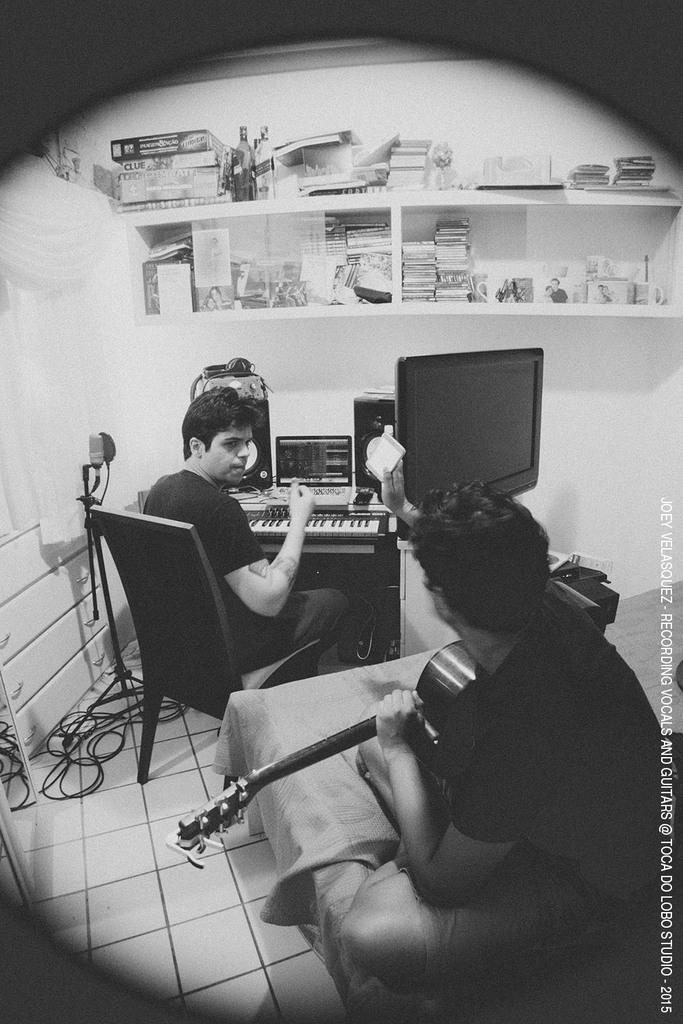What type of furniture is present in the image? There is a chair in the image. What type of electronic device is present in the image? There is a television in the image. What activity is the person in the image engaged in? A person is playing a guitar in the image. What type of storage or display area is present in the image? There are objects on a shelf in the image. What type of wiring or connection is present on the floor in the image? There are cables on the floor in the image. What type of coach is present in the image? There is no coach present in the image. What type of doctor is present in the image? There is no doctor present in the image. What type of slave is present in the image? There is no slave present in the image. 